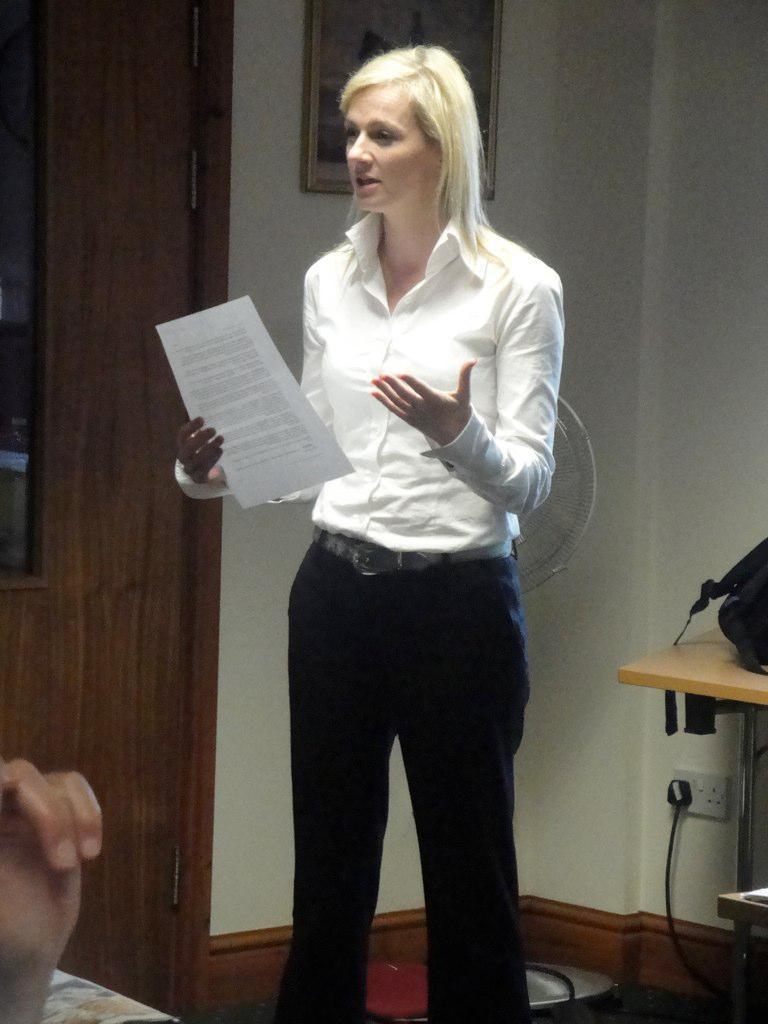How would you summarize this image in a sentence or two? This image consists of a woman. She is wearing a white shirt. She is holding a paper. There is a table on the right side. There is a photo frame at the top. There is a door on the left side. 